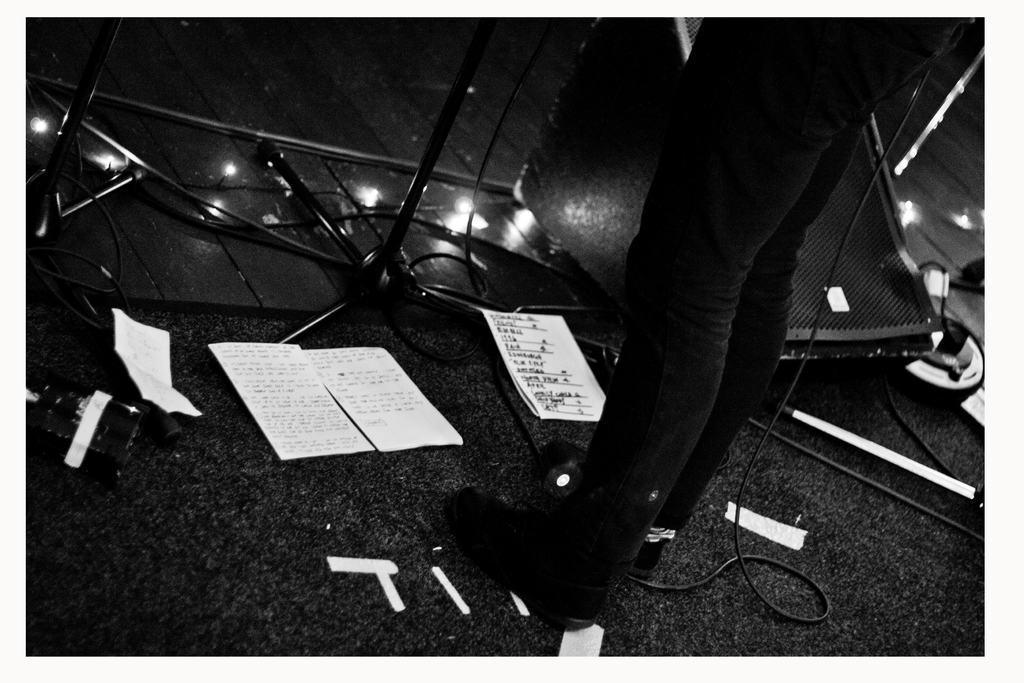Describe this image in one or two sentences. This is a black and white picture. In the foreground of the picture there are papers, cables and a person. On the right there are speaker and cables. On the left there are cables and stands. 